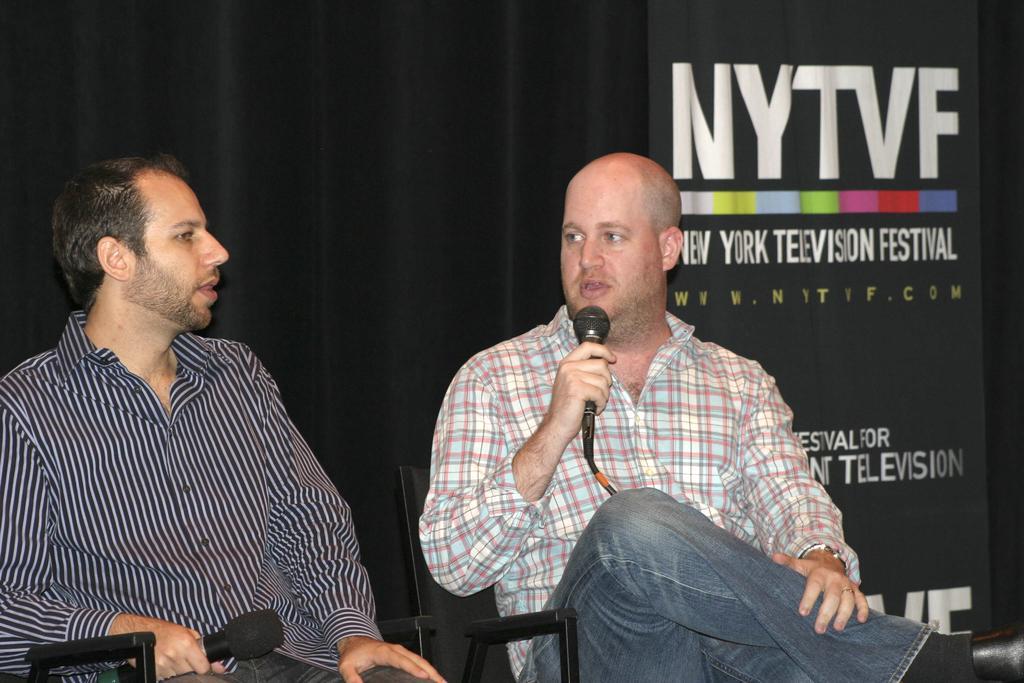In one or two sentences, can you explain what this image depicts? On the background we can see a board, hoarding board. We can see this man sitting on chair holding a mike in his and talking. Beside to him, we can see other man sitting on a chair and holding a mike in his hand. 